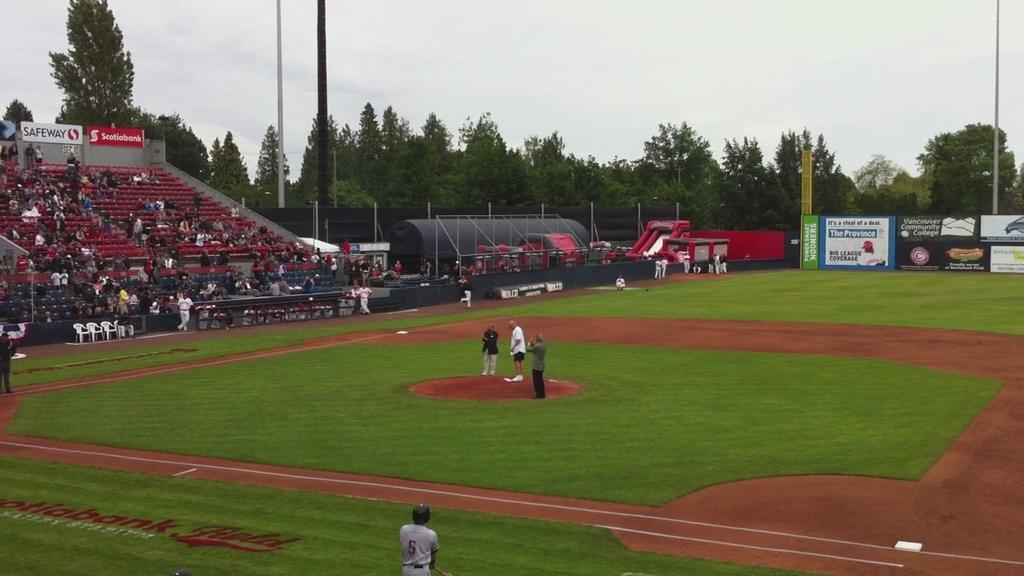Describe this image in one or two sentences. In the center of the image we can see some people are standing in the ground. On the left side of the image we can see some people are sitting in the auditorium and some of them are standing. In the background of the image we can see the rods, chairs, boards, poles, trees, ground. In the bottom left corner we can see the text on the ground. At the top of the image we can see the sky. 